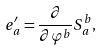Convert formula to latex. <formula><loc_0><loc_0><loc_500><loc_500>e ^ { \prime } _ { a } = \frac { \partial } { \partial \varphi ^ { b } } S ^ { b } _ { \, a } ,</formula> 